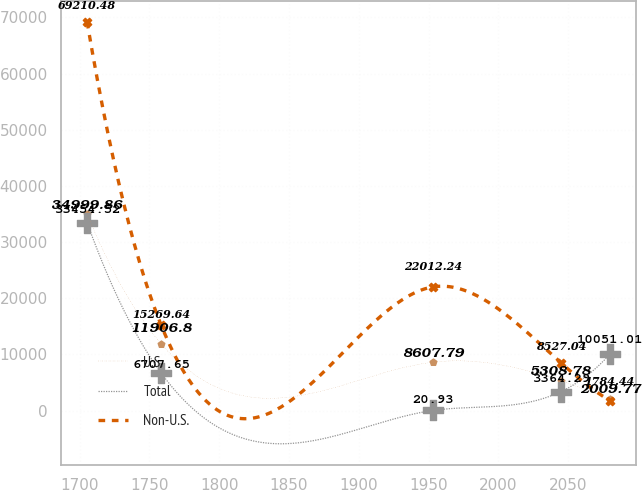<chart> <loc_0><loc_0><loc_500><loc_500><line_chart><ecel><fcel>U.S.<fcel>Total<fcel>Non-U.S.<nl><fcel>1705.39<fcel>34999.9<fcel>33454.5<fcel>69210.5<nl><fcel>1758.37<fcel>11906.8<fcel>6707.65<fcel>15269.6<nl><fcel>1952.99<fcel>8607.79<fcel>20.93<fcel>22012.2<nl><fcel>2044.74<fcel>5308.78<fcel>3364.29<fcel>8527.04<nl><fcel>2079.94<fcel>2009.77<fcel>10051<fcel>1784.44<nl></chart> 